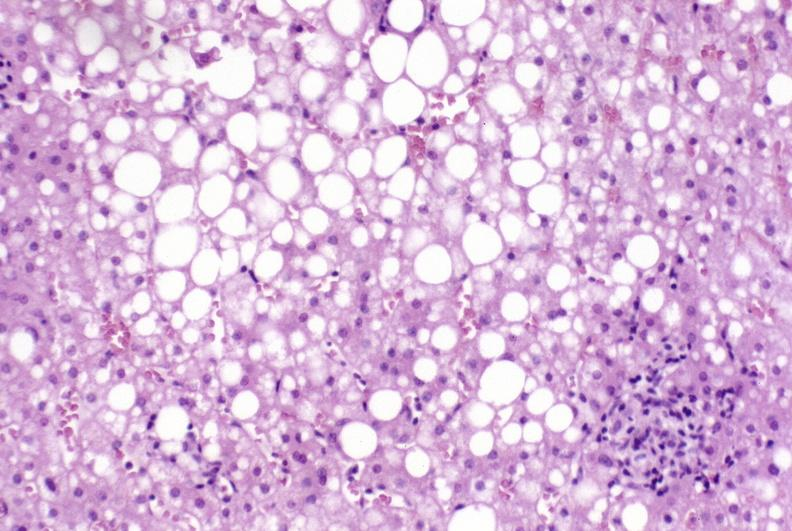does this image show primary biliary cirrhosis?
Answer the question using a single word or phrase. Yes 